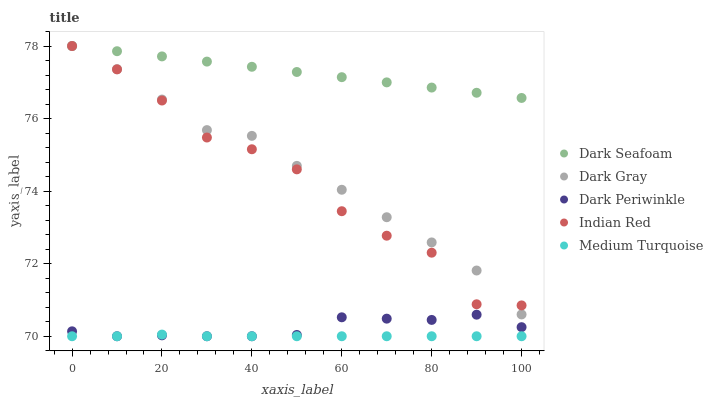Does Medium Turquoise have the minimum area under the curve?
Answer yes or no. Yes. Does Dark Seafoam have the maximum area under the curve?
Answer yes or no. Yes. Does Dark Periwinkle have the minimum area under the curve?
Answer yes or no. No. Does Dark Periwinkle have the maximum area under the curve?
Answer yes or no. No. Is Dark Seafoam the smoothest?
Answer yes or no. Yes. Is Indian Red the roughest?
Answer yes or no. Yes. Is Dark Periwinkle the smoothest?
Answer yes or no. No. Is Dark Periwinkle the roughest?
Answer yes or no. No. Does Dark Periwinkle have the lowest value?
Answer yes or no. Yes. Does Dark Seafoam have the lowest value?
Answer yes or no. No. Does Indian Red have the highest value?
Answer yes or no. Yes. Does Dark Periwinkle have the highest value?
Answer yes or no. No. Is Dark Periwinkle less than Indian Red?
Answer yes or no. Yes. Is Indian Red greater than Medium Turquoise?
Answer yes or no. Yes. Does Dark Gray intersect Indian Red?
Answer yes or no. Yes. Is Dark Gray less than Indian Red?
Answer yes or no. No. Is Dark Gray greater than Indian Red?
Answer yes or no. No. Does Dark Periwinkle intersect Indian Red?
Answer yes or no. No. 